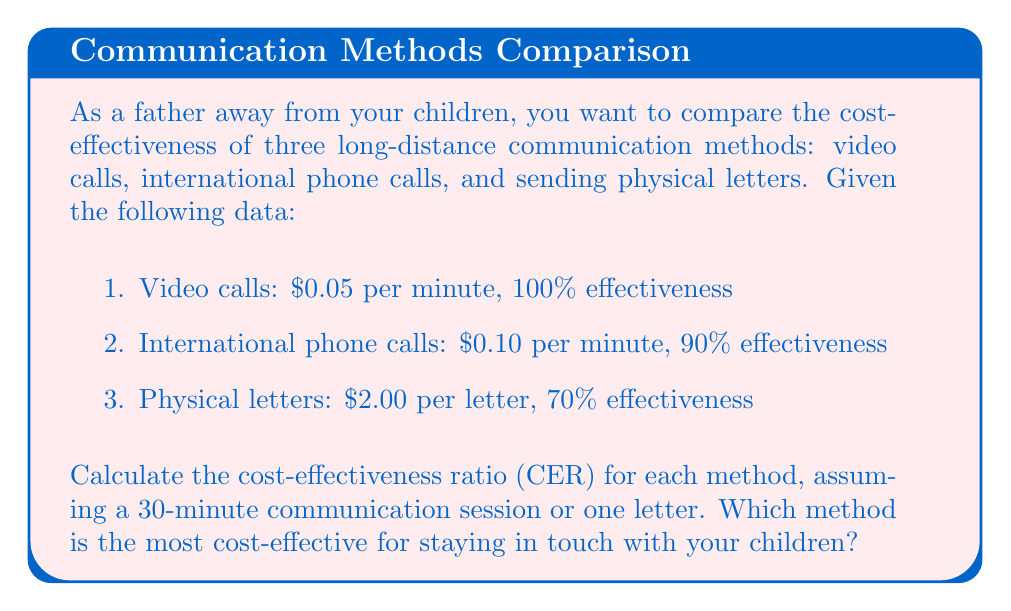Provide a solution to this math problem. To solve this problem, we need to calculate the Cost-Effectiveness Ratio (CER) for each communication method. The CER is defined as:

$$ CER = \frac{\text{Cost}}{\text{Effectiveness}} $$

Let's calculate the CER for each method:

1. Video calls:
   Cost = $0.05 \times 30 = $1.50
   Effectiveness = 100% = 1
   $$ CER_{video} = \frac{1.50}{1} = 1.50 $$

2. International phone calls:
   Cost = $0.10 \times 30 = $3.00
   Effectiveness = 90% = 0.90
   $$ CER_{phone} = \frac{3.00}{0.90} = 3.33 $$

3. Physical letters:
   Cost = $2.00 per letter
   Effectiveness = 70% = 0.70
   $$ CER_{letter} = \frac{2.00}{0.70} = 2.86 $$

The lower the CER, the more cost-effective the method is. Comparing the CERs:

$$ CER_{video} = 1.50 < CER_{letter} = 2.86 < CER_{phone} = 3.33 $$

Therefore, video calls are the most cost-effective method for staying in touch with your children.
Answer: Video calls (CER = 1.50) 